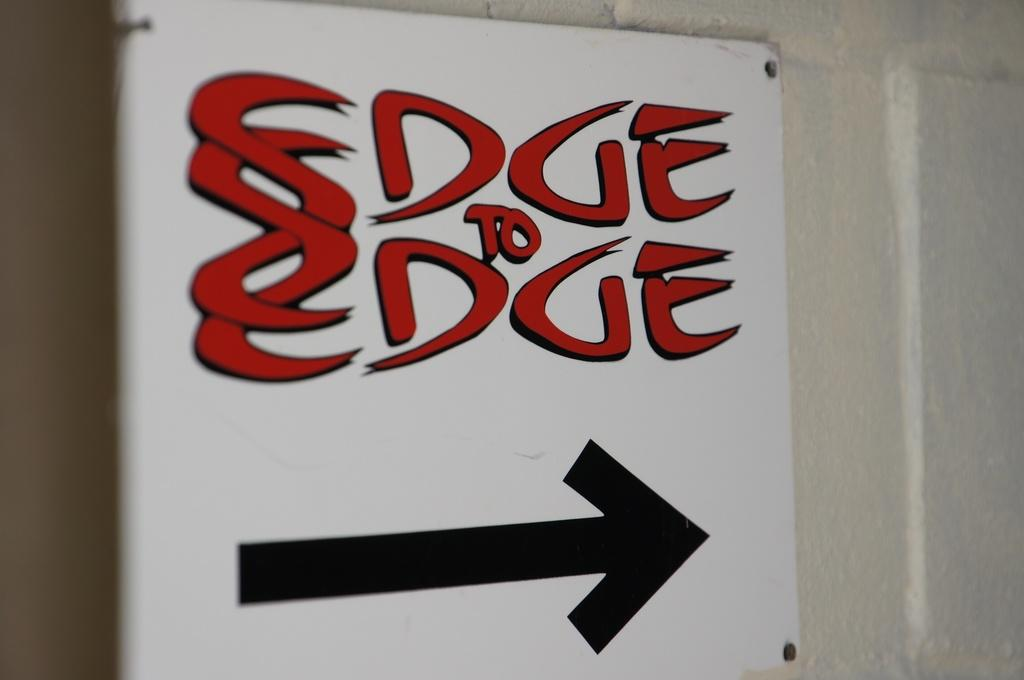<image>
Give a short and clear explanation of the subsequent image. An arrow appears below the words Edge to Edge. 